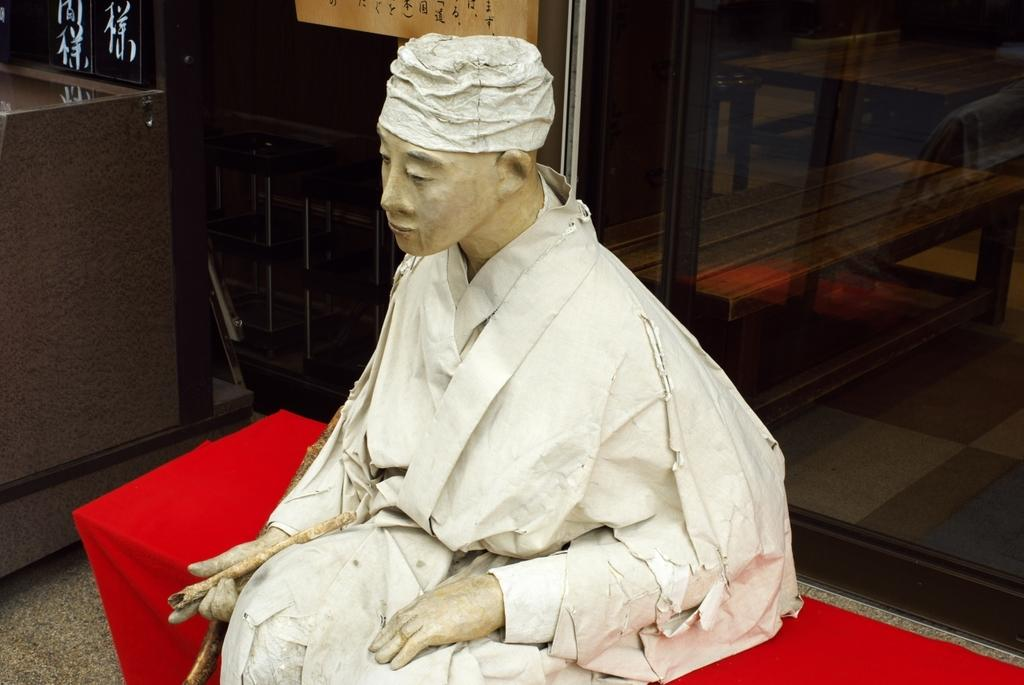What is the main subject in the image? There is a statue in the image. Can you describe the statue's surroundings? There is a glass behind the statue in the image. What type of picture is hanging on the wall behind the statue? There is no mention of a picture or a wall in the provided facts, so we cannot determine if there is a picture hanging on the wall behind the statue. 